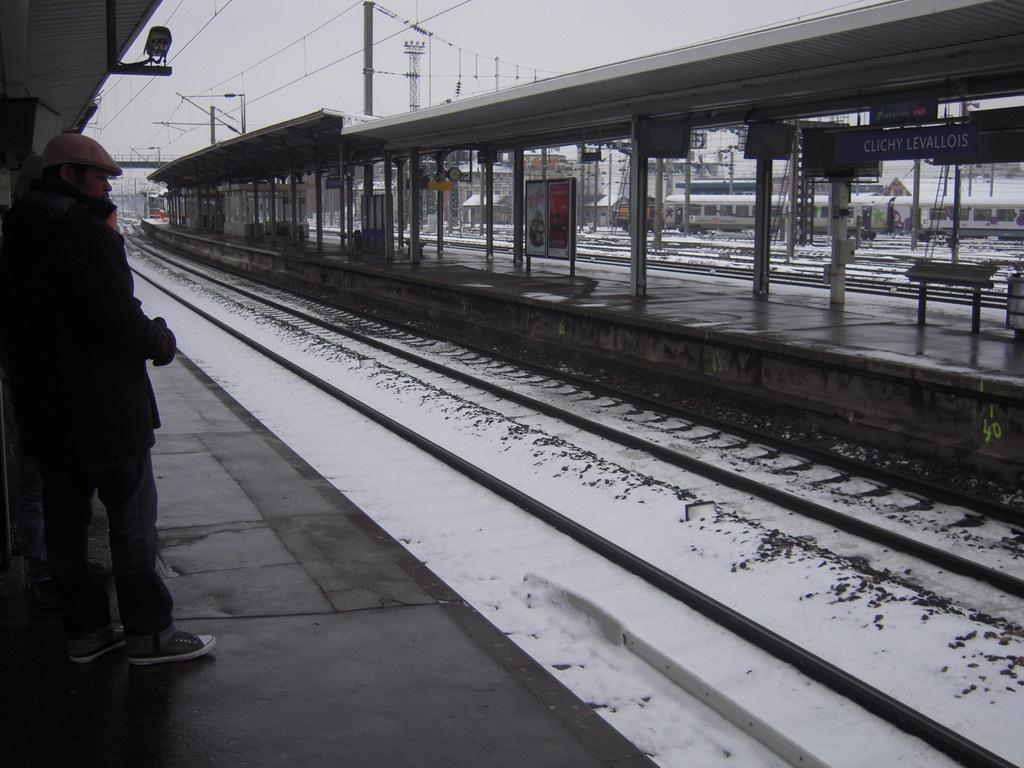Describe this image in one or two sentences. On the left side there is a platform. On that a person is standing wearing a cap. Near to that there is a railway track with snow. On the right side there is a platform with poles and some boards. In the background there is a train, electric poles, wires. 